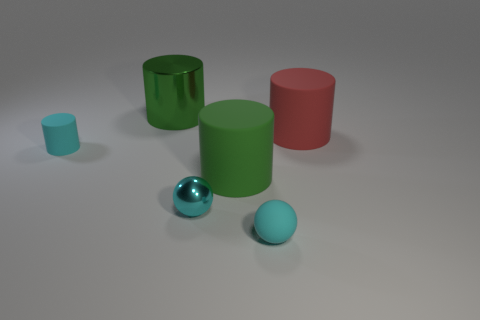Could these objects be part of a learning aid for children? Yes, the colorful cylinders and the sphere could serve as educational tools for teaching children about shapes, sizes, and colors in a tactile and visual way. 